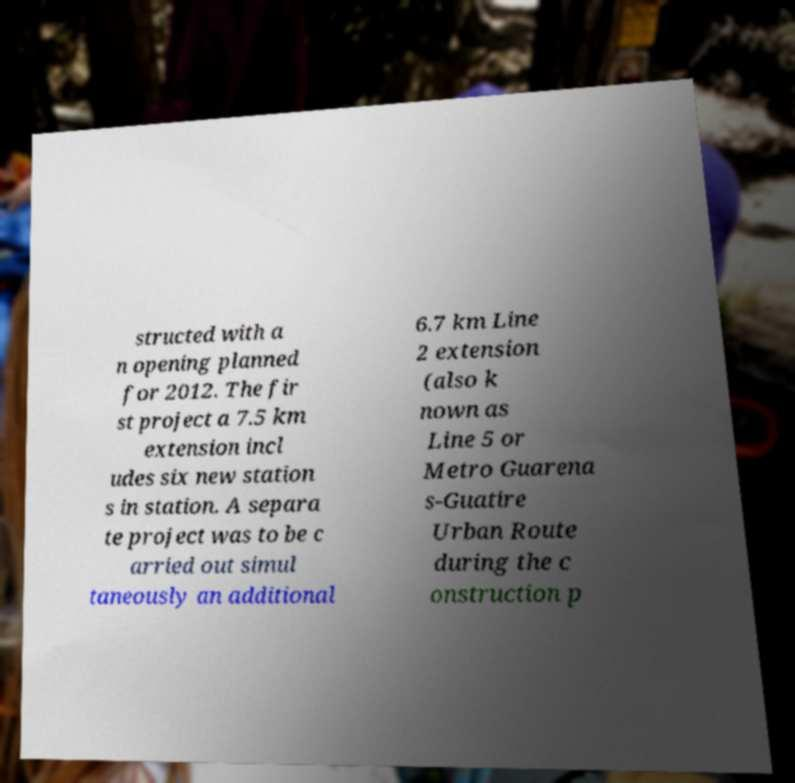Can you accurately transcribe the text from the provided image for me? structed with a n opening planned for 2012. The fir st project a 7.5 km extension incl udes six new station s in station. A separa te project was to be c arried out simul taneously an additional 6.7 km Line 2 extension (also k nown as Line 5 or Metro Guarena s-Guatire Urban Route during the c onstruction p 